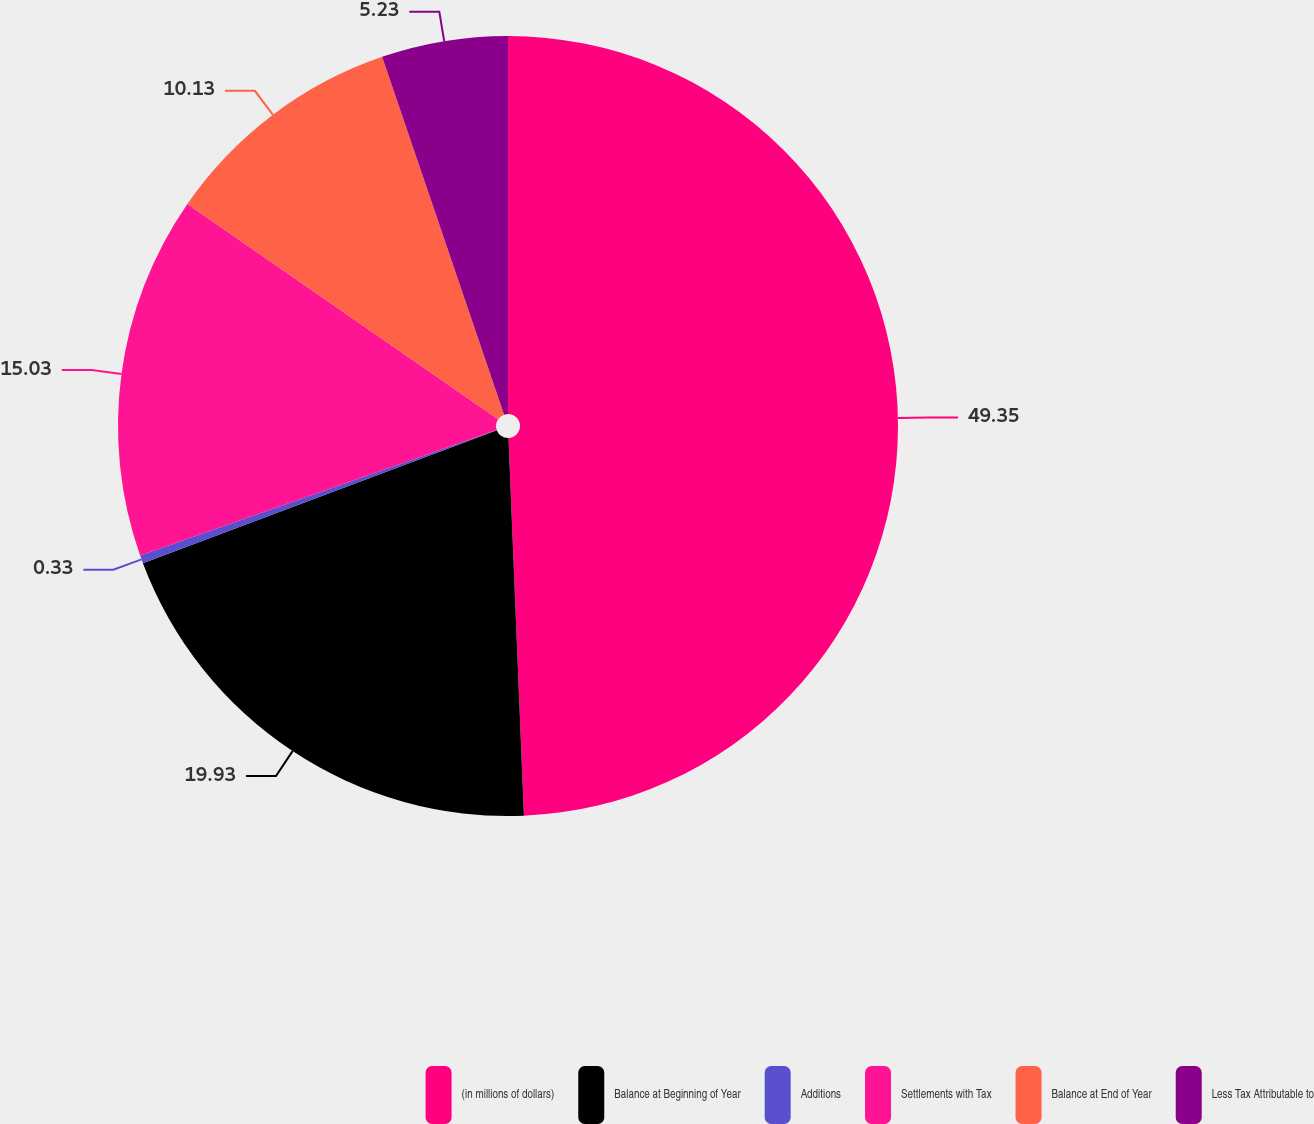Convert chart. <chart><loc_0><loc_0><loc_500><loc_500><pie_chart><fcel>(in millions of dollars)<fcel>Balance at Beginning of Year<fcel>Additions<fcel>Settlements with Tax<fcel>Balance at End of Year<fcel>Less Tax Attributable to<nl><fcel>49.35%<fcel>19.93%<fcel>0.33%<fcel>15.03%<fcel>10.13%<fcel>5.23%<nl></chart> 